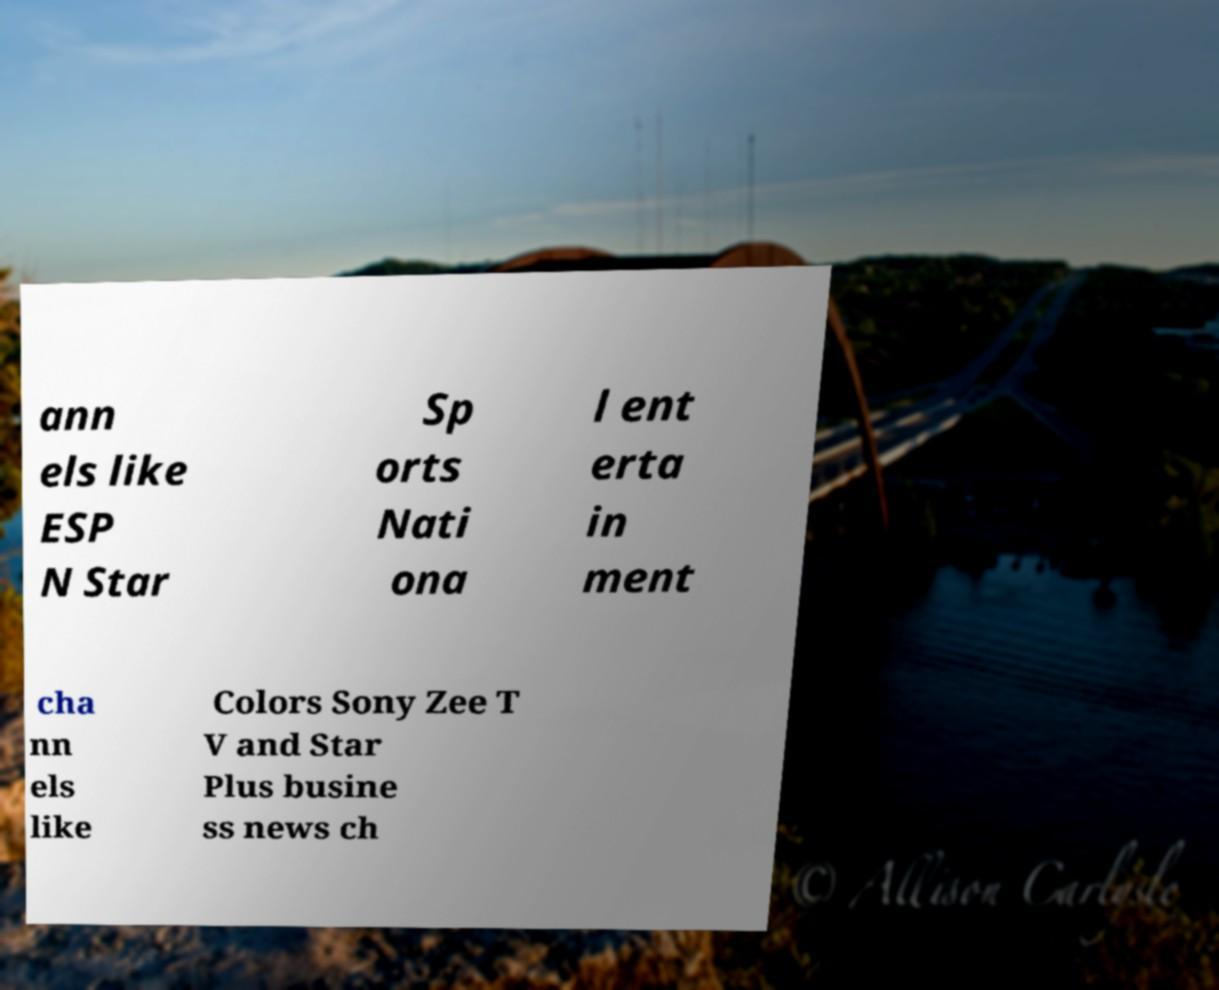Can you accurately transcribe the text from the provided image for me? ann els like ESP N Star Sp orts Nati ona l ent erta in ment cha nn els like Colors Sony Zee T V and Star Plus busine ss news ch 